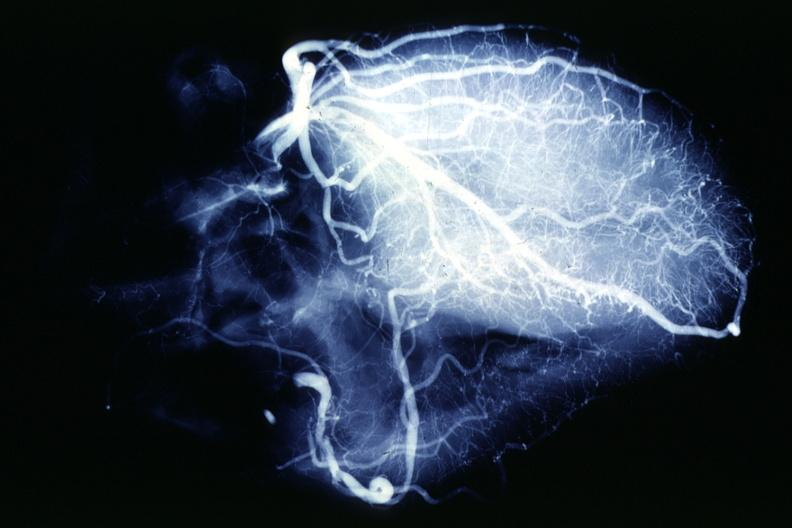s coronary atherosclerosis present?
Answer the question using a single word or phrase. Yes 